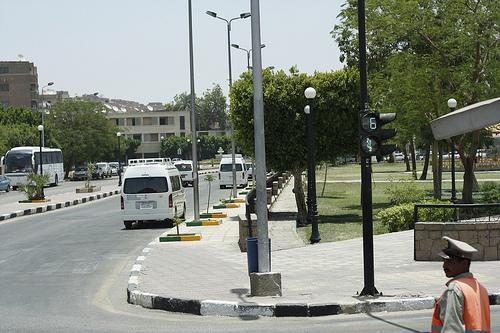Describe the main focus of the image using descriptive language. An urban landscape bustles with life, as vehicles traverse the roadways, people navigate the streets, and infrastructure like street lamps and buildings provide a comforting sense of order. Illustrate the details of the street lamps visible in the image. A series of double-lamp street lights and two black and white street lamps are along the road, with white globed lights atop the lamps. Mention the unique details observed in the image. There's a security camera installed on one of the poles, a metal rail on a low stone wall, and a young sapling tree planted along the walkway. Provide a brief overview of the image. The image features a busy street with cars, vans, and a bus driving along, while pedestrians and a crossing guard are present near multiple white and black street lamps, a sidewalk with planters, and a beige office building. Describe the scene related to the vehicles in the image. Three white vans with raised roofs are driving on the road next to a parked white van and a white public service bus, with cars parked on the left side of the road. Explain what the people in this image are doing in relation to their roles. A crossing guard and a police officer, both wearing orange vests, are attending to their duties, while a man dons a tan hat and other pedestrians walk by. Comment on the traffic signs and signals in the image. The image shows an electric pedestrian crossing sign, an electric traffic signal, a traffic light with a timer, and a number 6 on a crosswalk light. Give a brief summary of the contents of the image while focusing on the central elements. The central focus reveals a lively urban street shared by pedestrians, crossing guards, vehicles, street lamps, and various amenities like sidewalk planters, trash bins, and traffic signs. What are the prominent elements around the sidewalk in the image? The sidewalk includes a beige brick path, black and white striped curbs, small trees with green and yellow planters, and a blue trash bin near a street lamp. Paint a picture of the image by highlighting the key objects and their surroundings. The city street is an intricate tapestry weaved with stylish street lamps, a beige office building draped with bushes, the choreography of pedestrians and crossing guards, and the energetic stream of white vans and buses. 